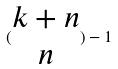Convert formula to latex. <formula><loc_0><loc_0><loc_500><loc_500>( \begin{matrix} k + n \\ n \end{matrix} ) - 1</formula> 